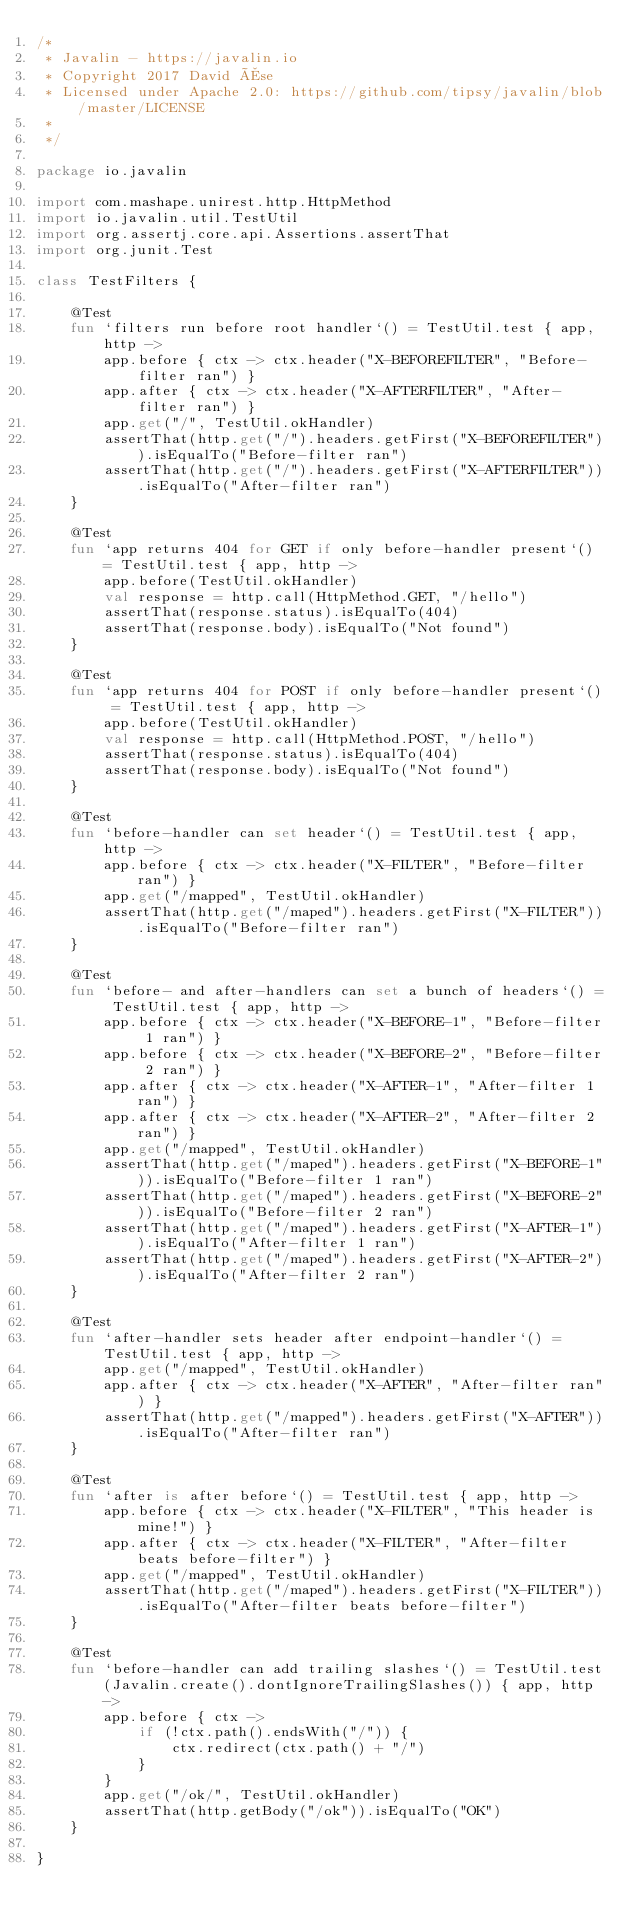Convert code to text. <code><loc_0><loc_0><loc_500><loc_500><_Kotlin_>/*
 * Javalin - https://javalin.io
 * Copyright 2017 David Åse
 * Licensed under Apache 2.0: https://github.com/tipsy/javalin/blob/master/LICENSE
 *
 */

package io.javalin

import com.mashape.unirest.http.HttpMethod
import io.javalin.util.TestUtil
import org.assertj.core.api.Assertions.assertThat
import org.junit.Test

class TestFilters {

    @Test
    fun `filters run before root handler`() = TestUtil.test { app, http ->
        app.before { ctx -> ctx.header("X-BEFOREFILTER", "Before-filter ran") }
        app.after { ctx -> ctx.header("X-AFTERFILTER", "After-filter ran") }
        app.get("/", TestUtil.okHandler)
        assertThat(http.get("/").headers.getFirst("X-BEFOREFILTER")).isEqualTo("Before-filter ran")
        assertThat(http.get("/").headers.getFirst("X-AFTERFILTER")).isEqualTo("After-filter ran")
    }

    @Test
    fun `app returns 404 for GET if only before-handler present`() = TestUtil.test { app, http ->
        app.before(TestUtil.okHandler)
        val response = http.call(HttpMethod.GET, "/hello")
        assertThat(response.status).isEqualTo(404)
        assertThat(response.body).isEqualTo("Not found")
    }

    @Test
    fun `app returns 404 for POST if only before-handler present`() = TestUtil.test { app, http ->
        app.before(TestUtil.okHandler)
        val response = http.call(HttpMethod.POST, "/hello")
        assertThat(response.status).isEqualTo(404)
        assertThat(response.body).isEqualTo("Not found")
    }

    @Test
    fun `before-handler can set header`() = TestUtil.test { app, http ->
        app.before { ctx -> ctx.header("X-FILTER", "Before-filter ran") }
        app.get("/mapped", TestUtil.okHandler)
        assertThat(http.get("/maped").headers.getFirst("X-FILTER")).isEqualTo("Before-filter ran")
    }

    @Test
    fun `before- and after-handlers can set a bunch of headers`() = TestUtil.test { app, http ->
        app.before { ctx -> ctx.header("X-BEFORE-1", "Before-filter 1 ran") }
        app.before { ctx -> ctx.header("X-BEFORE-2", "Before-filter 2 ran") }
        app.after { ctx -> ctx.header("X-AFTER-1", "After-filter 1 ran") }
        app.after { ctx -> ctx.header("X-AFTER-2", "After-filter 2 ran") }
        app.get("/mapped", TestUtil.okHandler)
        assertThat(http.get("/maped").headers.getFirst("X-BEFORE-1")).isEqualTo("Before-filter 1 ran")
        assertThat(http.get("/maped").headers.getFirst("X-BEFORE-2")).isEqualTo("Before-filter 2 ran")
        assertThat(http.get("/maped").headers.getFirst("X-AFTER-1")).isEqualTo("After-filter 1 ran")
        assertThat(http.get("/maped").headers.getFirst("X-AFTER-2")).isEqualTo("After-filter 2 ran")
    }

    @Test
    fun `after-handler sets header after endpoint-handler`() = TestUtil.test { app, http ->
        app.get("/mapped", TestUtil.okHandler)
        app.after { ctx -> ctx.header("X-AFTER", "After-filter ran") }
        assertThat(http.get("/mapped").headers.getFirst("X-AFTER")).isEqualTo("After-filter ran")
    }

    @Test
    fun `after is after before`() = TestUtil.test { app, http ->
        app.before { ctx -> ctx.header("X-FILTER", "This header is mine!") }
        app.after { ctx -> ctx.header("X-FILTER", "After-filter beats before-filter") }
        app.get("/mapped", TestUtil.okHandler)
        assertThat(http.get("/maped").headers.getFirst("X-FILTER")).isEqualTo("After-filter beats before-filter")
    }

    @Test
    fun `before-handler can add trailing slashes`() = TestUtil.test(Javalin.create().dontIgnoreTrailingSlashes()) { app, http ->
        app.before { ctx ->
            if (!ctx.path().endsWith("/")) {
                ctx.redirect(ctx.path() + "/")
            }
        }
        app.get("/ok/", TestUtil.okHandler)
        assertThat(http.getBody("/ok")).isEqualTo("OK")
    }

}
</code> 